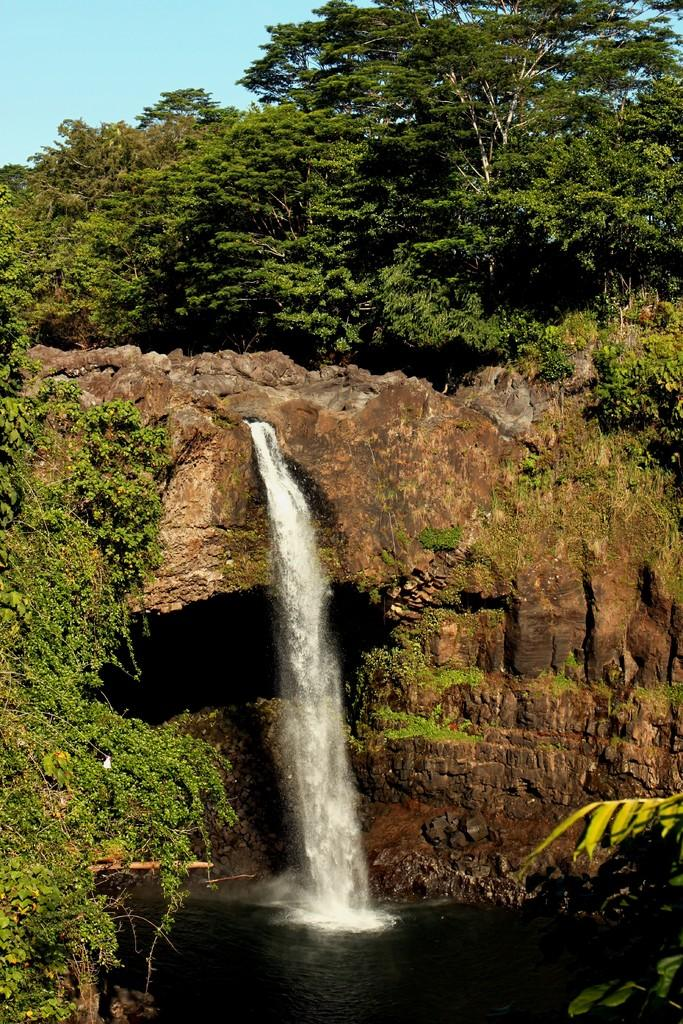What natural feature is the main subject of the image? There is a waterfall in the image. What type of vegetation can be seen in the image? There are trees in the background of the image. What else is visible in the background of the image? The sky is visible in the background of the image. What type of vegetable is growing near the waterfall in the image? There is no vegetable visible in the image; it only features a waterfall, trees, and the sky. 